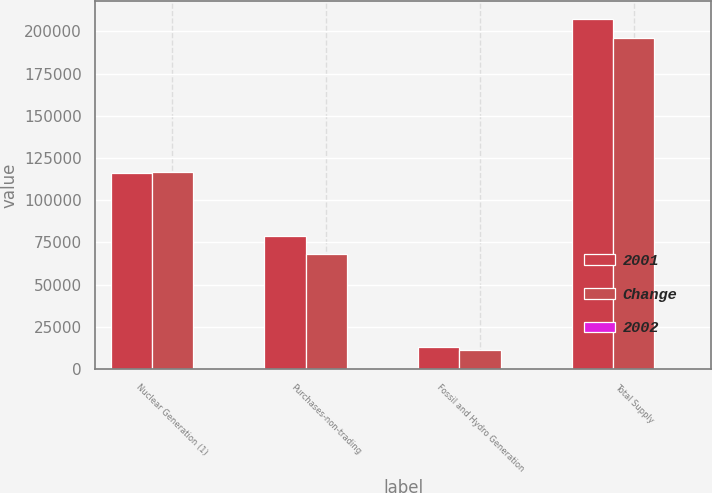<chart> <loc_0><loc_0><loc_500><loc_500><stacked_bar_chart><ecel><fcel>Nuclear Generation (1)<fcel>Purchases-non-trading<fcel>Fossil and Hydro Generation<fcel>Total Supply<nl><fcel>2001<fcel>115854<fcel>78710<fcel>12976<fcel>207540<nl><fcel>Change<fcel>116839<fcel>67942<fcel>11345<fcel>196126<nl><fcel>2002<fcel>0.8<fcel>15.8<fcel>14.4<fcel>5.8<nl></chart> 